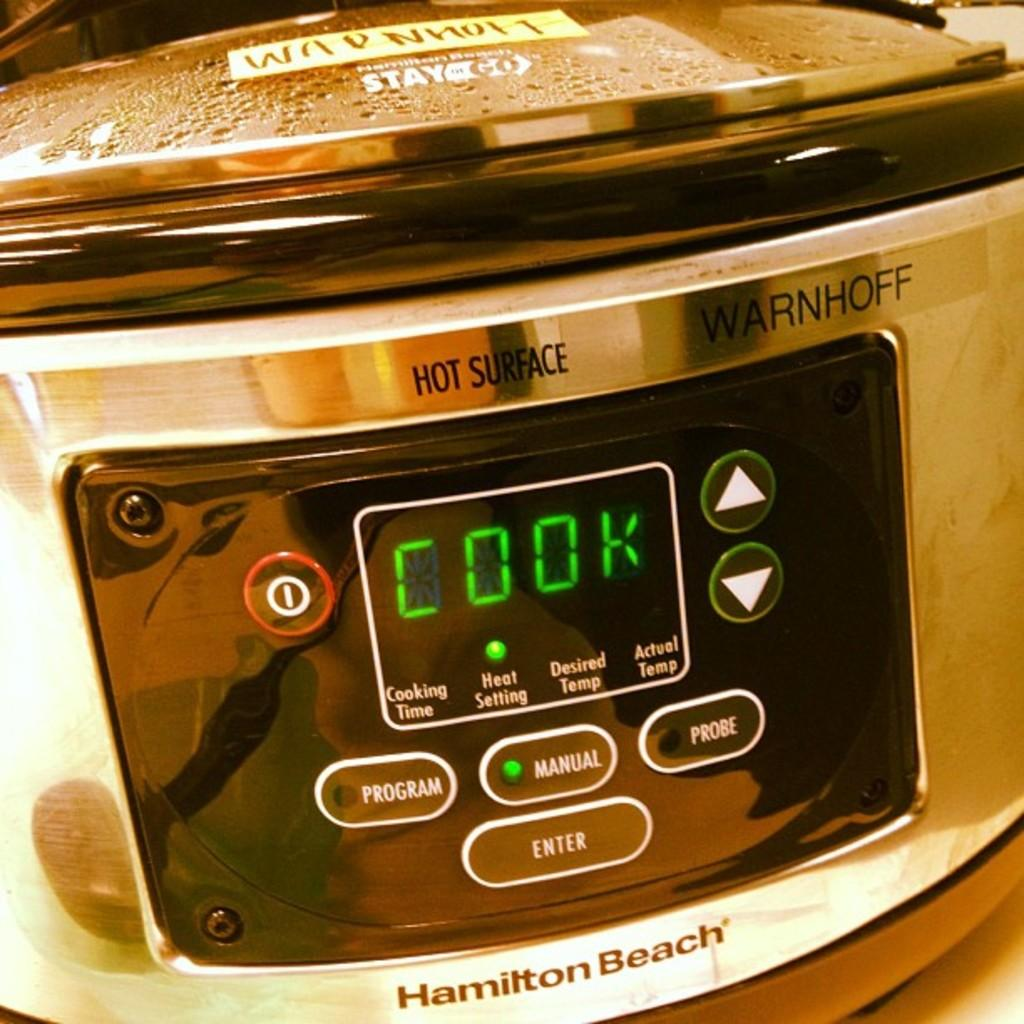<image>
Share a concise interpretation of the image provided. A Hamilton Beach product is on the cook heat setting. 